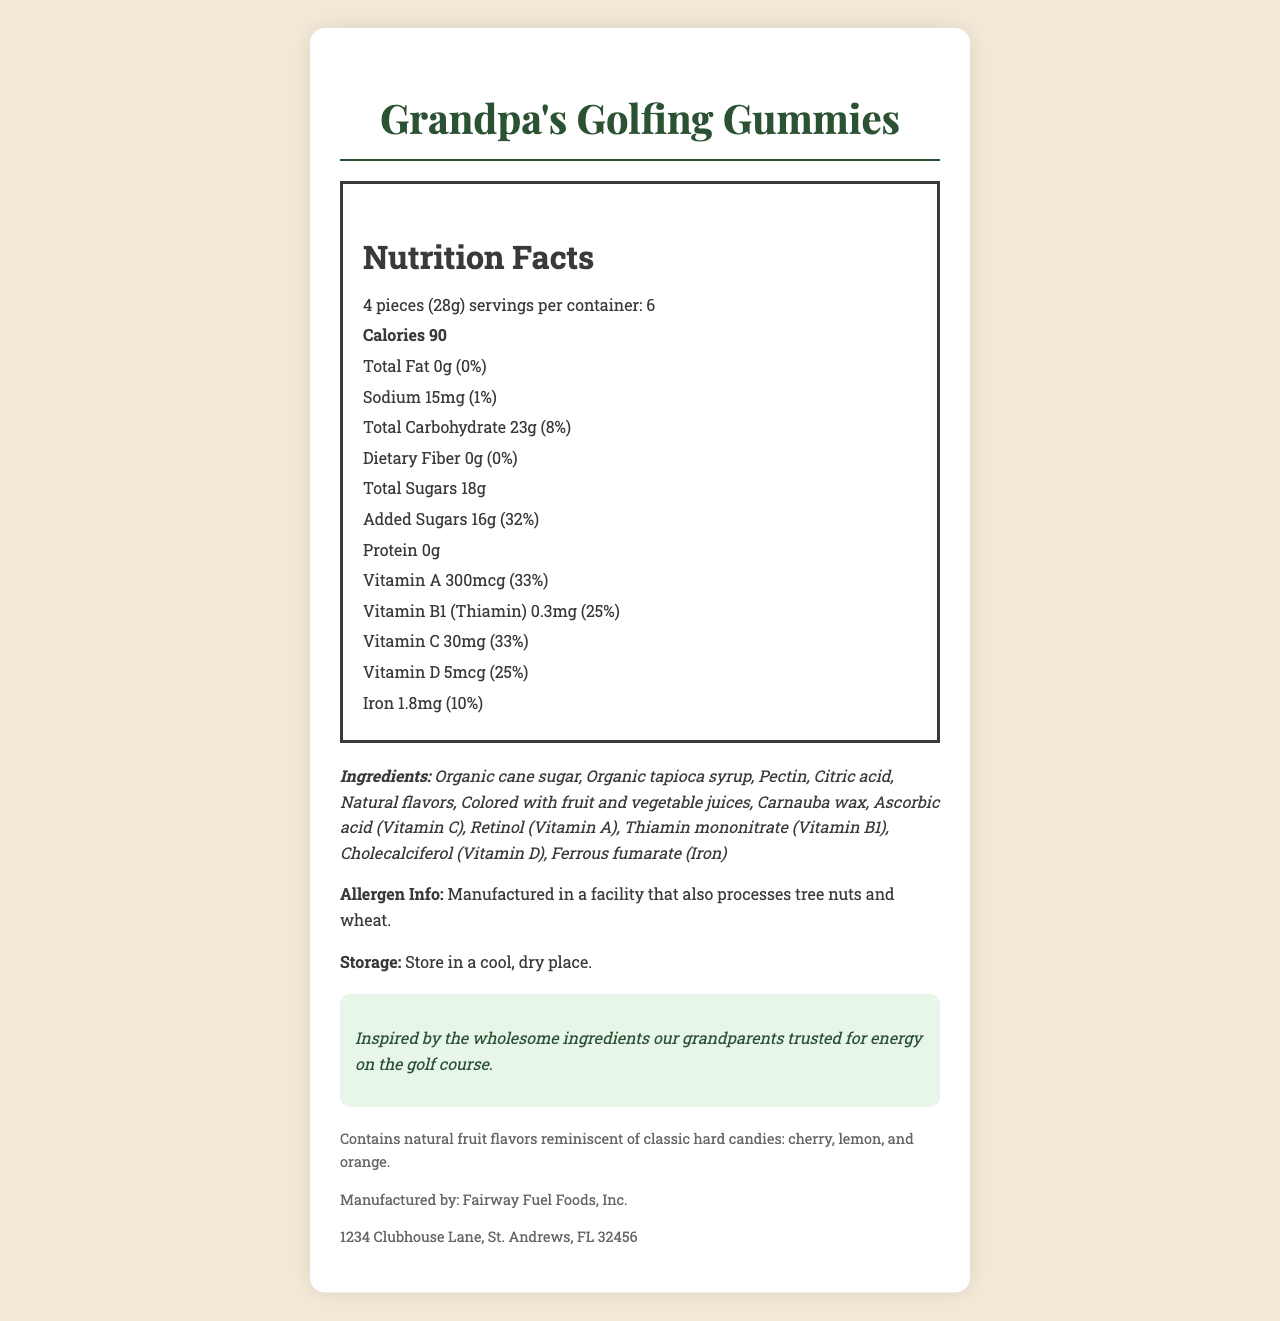what is the serving size for Grandpa's Golfing Gummies? The serving size is stated directly on the label as "4 pieces (28g)".
Answer: 4 pieces (28g) how many servings are in a container? The label indicates there are 6 servings per container.
Answer: 6 servings what are the total calories per serving? The nutrition label states that each serving contains 90 calories.
Answer: 90 calories What is the total amount of sugars per serving? The nutrition label states that the total amount of sugars per serving is 18g.
Answer: 18g What is the daily value percentage of Vitamin C? The daily value percentage for Vitamin C is listed as 33% on the nutrition label.
Answer: 33% Which ingredient is not natural? A. Organic cane sugar B. Citric acid C. Carnauba wax Organic cane sugar and Carnauba wax are natural, while Citric acid is a processed ingredient.
Answer: B How much sodium is in one serving? The nutrition label states that one serving contains 15mg of sodium.
Answer: 15mg Which vitamin has the highest daily value percentage in one serving? A. Vitamin A B. Vitamin C C. Vitamin B1 (Thiamin) Vitamin A has the highest daily value percentage at 33%.
Answer: A Does this product contain any protein? The nutrition label indicates that there is 0g of protein per serving.
Answer: No is the product suitable for someone with a tree nut allergy? The allergen info states that the product is manufactured in a facility that also processes tree nuts.
Answer: No Summarize the main idea of the document. The document provides comprehensive information about Grandpa's Golfing Gummies, including nutritional content, ingredients, allergen warnings, and manufacturer details, emphasizing the use of natural ingredients and vitamins that were popular in the past for energy.
Answer: Grandpa's Golfing Gummies are vintage-inspired energy chews with natural ingredients and vitamins reminiscent of the ingredients our grandparents trusted. The product has detailed nutrition facts, ingredients, allergen information, storage instructions, and is manufactured by Fairway Fuel Foods, Inc. what is the function of pectin in Grandpa's Golfing Gummies? The document does not provide information on the specific function of pectin in the product.
Answer: Cannot be determined 